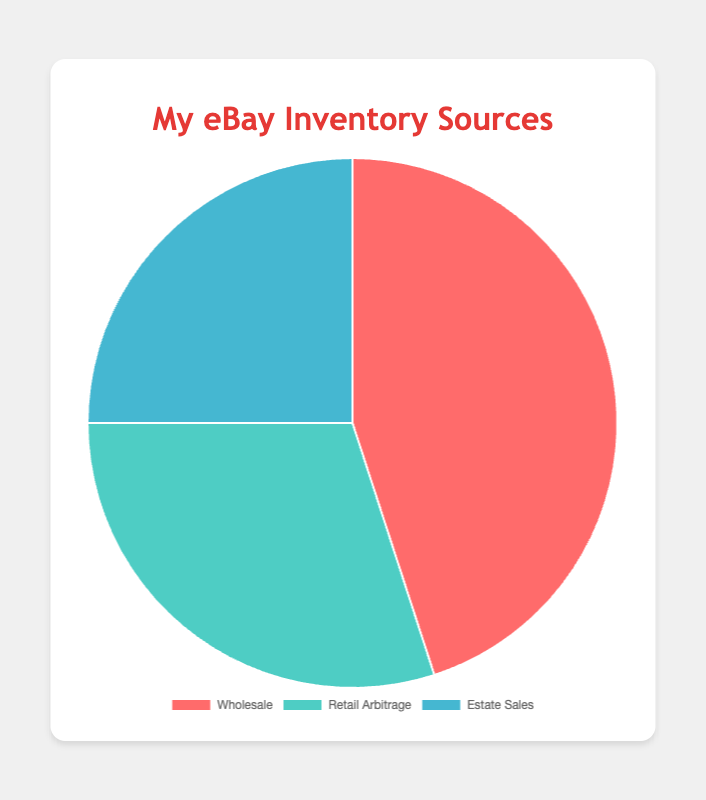Which inventory source has the highest percentage? By looking at the pie chart, the sector representing the largest portion will correspond to the highest percentage. Wholesale, which takes up the largest segment of the pie chart, has 45%.
Answer: Wholesale What is the combined percentage of Retail Arbitrage and Estate Sales? Add the percentages of Retail Arbitrage (30%) and Estate Sales (25%). Thus, 30% + 25% = 55%.
Answer: 55% Which inventory source has the smallest percentage? The smallest segment in the pie chart will correspond to the smallest percentage. Estate Sales, which is the smallest segment, has 25%.
Answer: Estate Sales How much larger is the Wholesale percentage compared to Estate Sales? Subtract the percentage of Estate Sales (25%) from the percentage of Wholesale (45%). Thus, 45% - 25% = 20%.
Answer: 20% Are the percentages of Retail Arbitrage and Estate Sales together greater than Wholesale? Calculate and compare the sum of Retail Arbitrage (30%) and Estate Sales (25%) with Wholesale (45%): 30% + 25% = 55%, which is greater than 45%.
Answer: Yes Which segment is represented by the light blue color? By looking at the legend of the pie chart, the segment represented in light blue corresponds to Estate Sales.
Answer: Estate Sales How much more inventory percentage does Wholesale account for compared to the combined percentage of Retail Arbitrage and Estate Sales? First calculate the combined percentage of Retail Arbitrage and Estate Sales: 30% + 25% = 55%. Then subtract Wholesale’s percentage from this sum: 55% - 45% = 10% more.
Answer: 10% Rank the sources of inventory from highest to lowest percentage. Based on the percentages provided: Wholesale (45%), Retail Arbitrage (30%), and Estate Sales (25%).
Answer: Wholesale, Retail Arbitrage, Estate Sales If you combine the percentages of the two smallest sources, how much less is it than the largest source? Add the percentages of Retail Arbitrage (30%) and Estate Sales (25%) to get 55%. Then subtract Wholesale's percentage (45%) from this sum: 55% - 45% = 10%.
Answer: 10% What percentage of the inventory does not come from Wholesale? Subtract the Wholesale percentage (45%) from 100% to find out the remaining: 100% - 45% = 55%.
Answer: 55% 